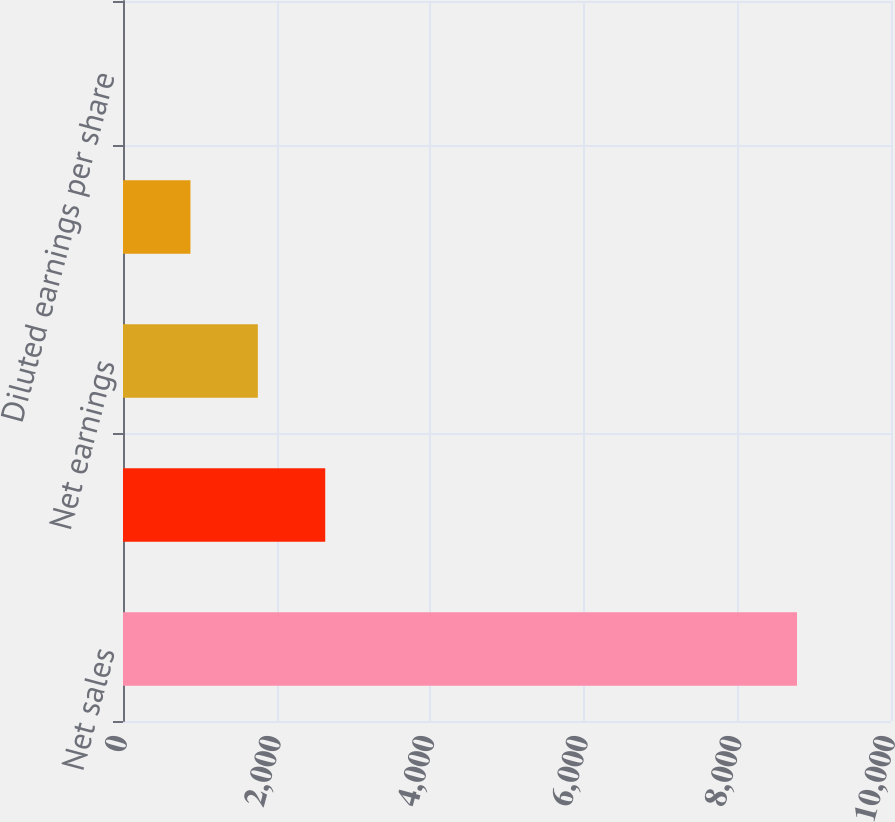Convert chart. <chart><loc_0><loc_0><loc_500><loc_500><bar_chart><fcel>Net sales<fcel>Operating profit<fcel>Net earnings<fcel>Basic earnings per share<fcel>Diluted earnings per share<nl><fcel>8776<fcel>2633.25<fcel>1755.72<fcel>878.19<fcel>0.66<nl></chart> 